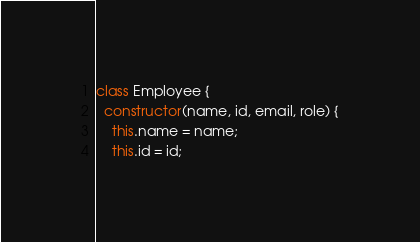Convert code to text. <code><loc_0><loc_0><loc_500><loc_500><_JavaScript_>class Employee {
  constructor(name, id, email, role) {
    this.name = name;
    this.id = id;</code> 